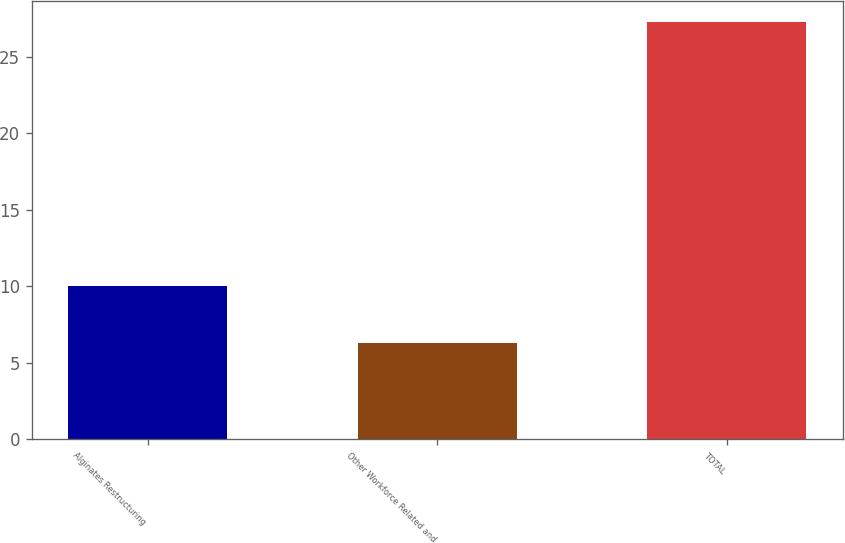Convert chart to OTSL. <chart><loc_0><loc_0><loc_500><loc_500><bar_chart><fcel>Alginates Restructuring<fcel>Other Workforce Related and<fcel>TOTAL<nl><fcel>10<fcel>6.3<fcel>27.3<nl></chart> 